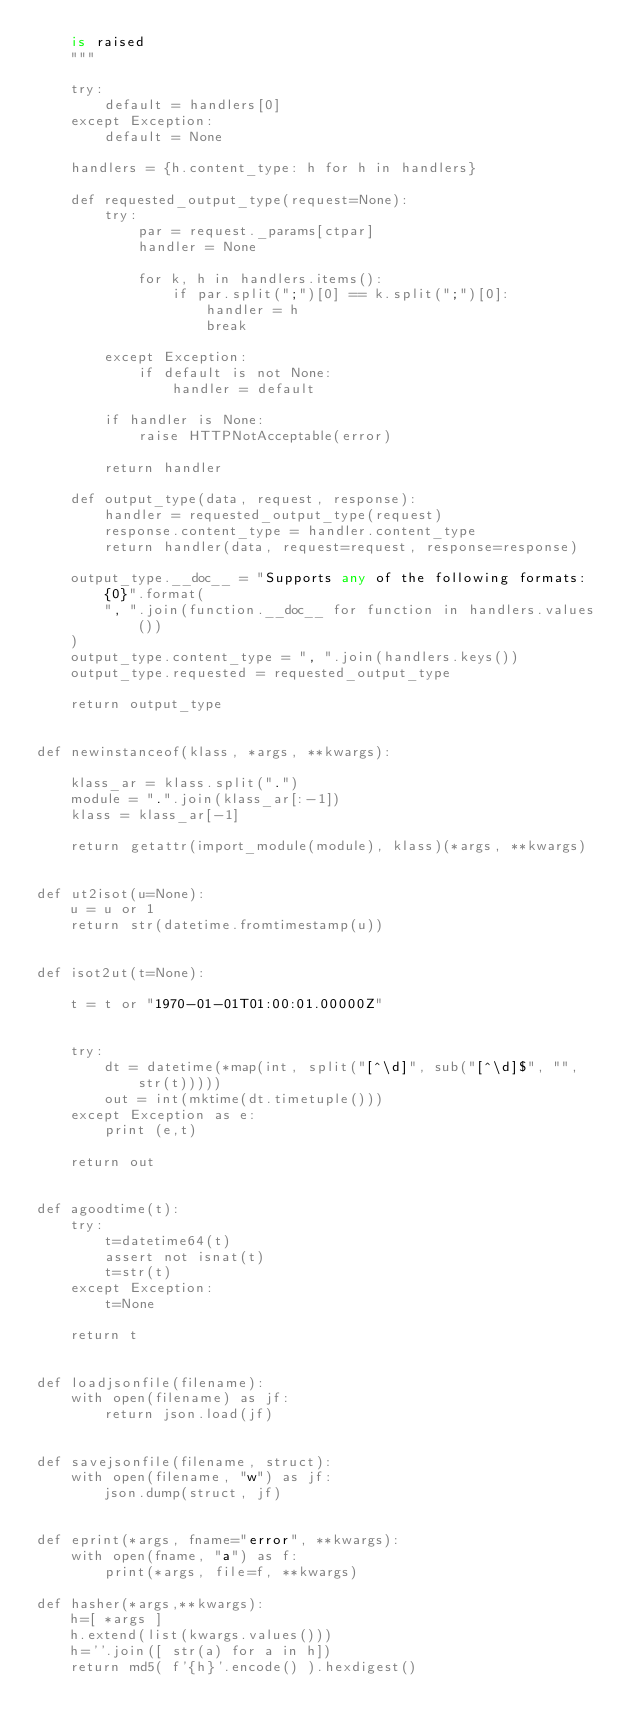Convert code to text. <code><loc_0><loc_0><loc_500><loc_500><_Python_>    is raised
    """

    try:
        default = handlers[0]
    except Exception:
        default = None

    handlers = {h.content_type: h for h in handlers}

    def requested_output_type(request=None):
        try:
            par = request._params[ctpar]
            handler = None

            for k, h in handlers.items():
                if par.split(";")[0] == k.split(";")[0]:
                    handler = h
                    break

        except Exception:
            if default is not None:
                handler = default

        if handler is None:
            raise HTTPNotAcceptable(error)

        return handler

    def output_type(data, request, response):
        handler = requested_output_type(request)
        response.content_type = handler.content_type
        return handler(data, request=request, response=response)

    output_type.__doc__ = "Supports any of the following formats: {0}".format(
        ", ".join(function.__doc__ for function in handlers.values())
    )
    output_type.content_type = ", ".join(handlers.keys())
    output_type.requested = requested_output_type

    return output_type


def newinstanceof(klass, *args, **kwargs):

    klass_ar = klass.split(".")
    module = ".".join(klass_ar[:-1])
    klass = klass_ar[-1]

    return getattr(import_module(module), klass)(*args, **kwargs)


def ut2isot(u=None):
    u = u or 1
    return str(datetime.fromtimestamp(u))


def isot2ut(t=None):

    t = t or "1970-01-01T01:00:01.00000Z"


    try:
        dt = datetime(*map(int, split("[^\d]", sub("[^\d]$", "", str(t)))))
        out = int(mktime(dt.timetuple()))
    except Exception as e:
        print (e,t)

    return out


def agoodtime(t):
    try:
        t=datetime64(t)
        assert not isnat(t)
        t=str(t)
    except Exception:
        t=None

    return t


def loadjsonfile(filename):
    with open(filename) as jf:
        return json.load(jf)


def savejsonfile(filename, struct):
    with open(filename, "w") as jf:
        json.dump(struct, jf)


def eprint(*args, fname="error", **kwargs):
    with open(fname, "a") as f:
        print(*args, file=f, **kwargs)

def hasher(*args,**kwargs):                                                                                                                           
    h=[ *args ]
    h.extend(list(kwargs.values()))
    h=''.join([ str(a) for a in h])
    return md5( f'{h}'.encode() ).hexdigest()

</code> 